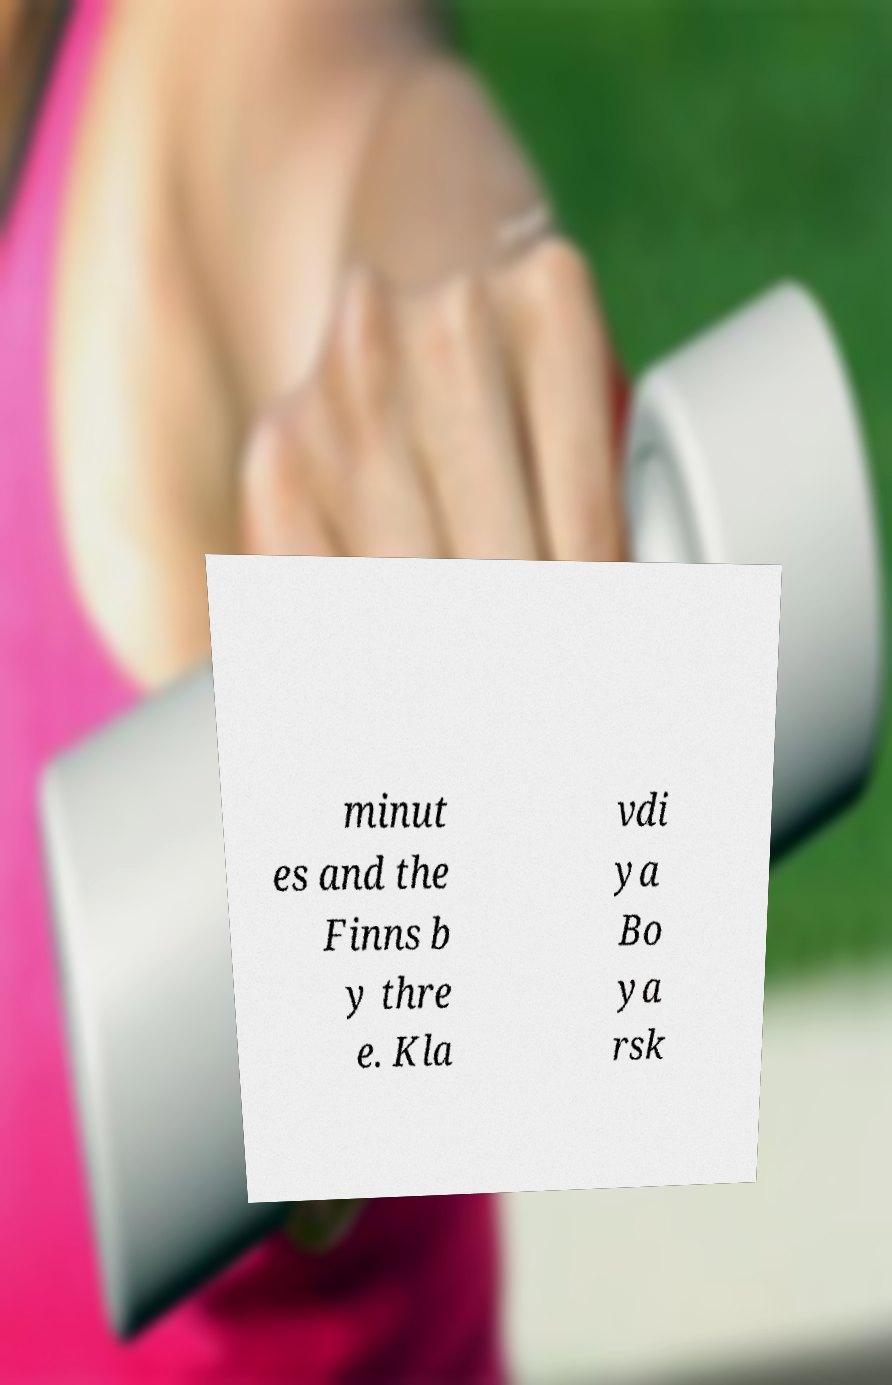There's text embedded in this image that I need extracted. Can you transcribe it verbatim? minut es and the Finns b y thre e. Kla vdi ya Bo ya rsk 